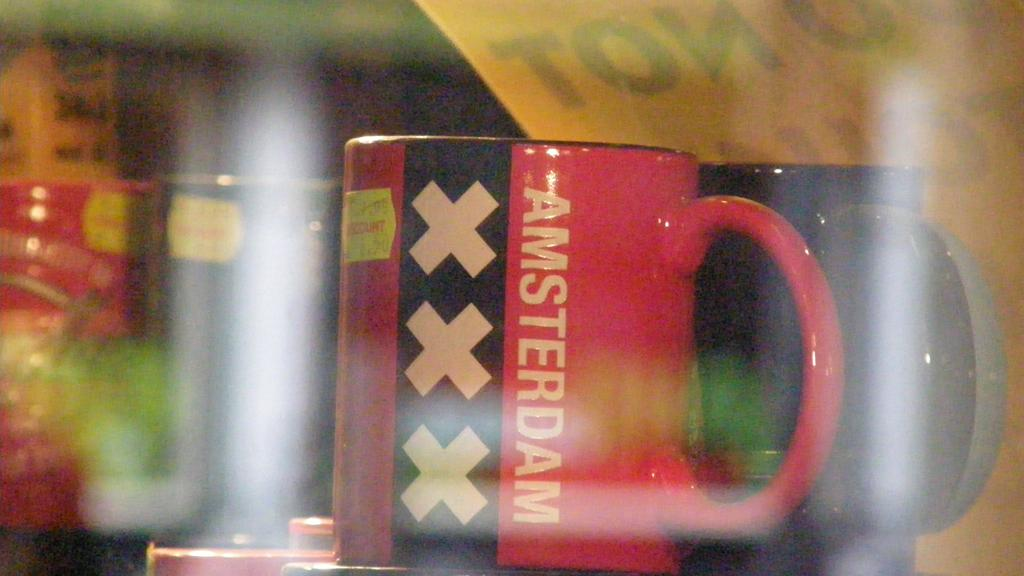<image>
Describe the image concisely. Two red and black mugs and one says Amsterdam in white letters. 